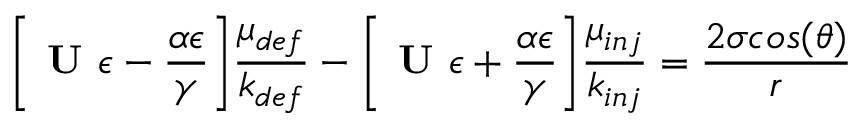<formula> <loc_0><loc_0><loc_500><loc_500>\left [ U \epsilon - \frac { \alpha \epsilon } { \gamma } \right ] \frac { \mu _ { d e f } } { k _ { d e f } } - \left [ U \epsilon + \frac { \alpha \epsilon } { \gamma } \right ] \frac { \mu _ { i n j } } { k _ { i n j } } = \frac { 2 \sigma \cos ( \theta ) } { r }</formula> 